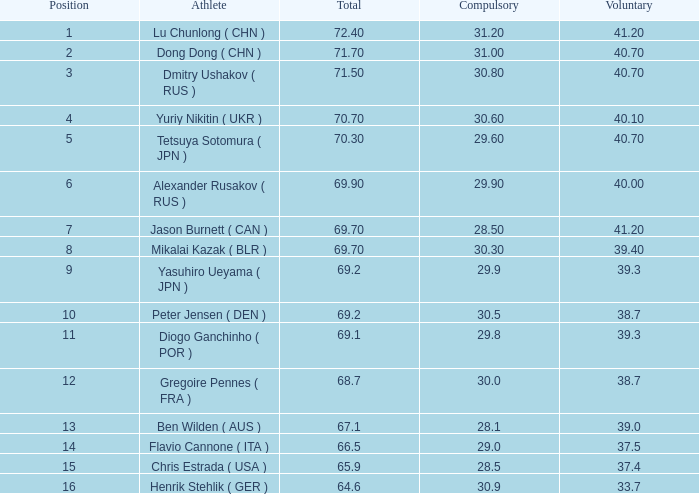What's the total compulsory when the total is more than 69.2 and the voluntary is 38.7? 0.0. 